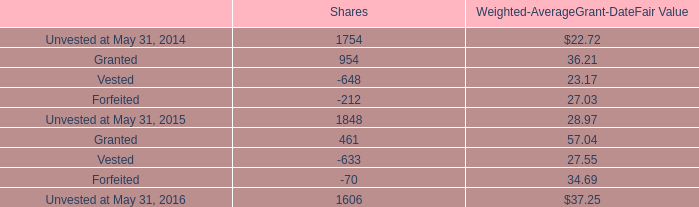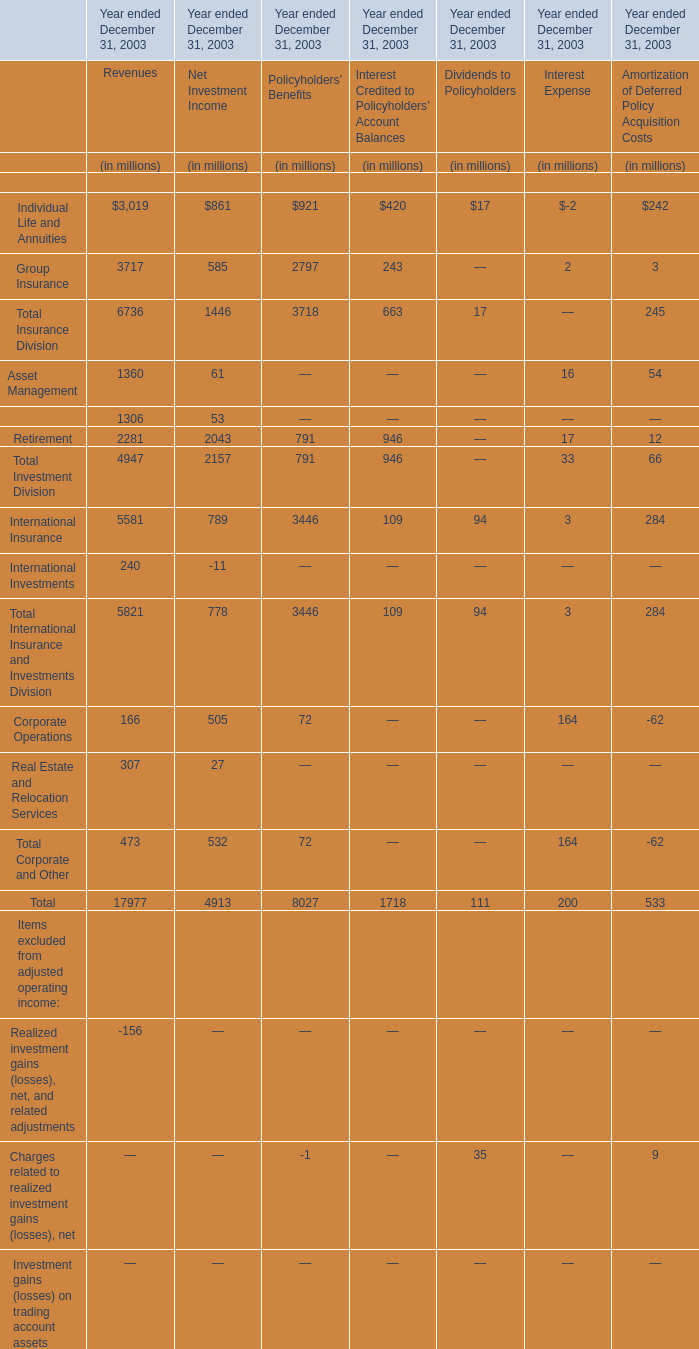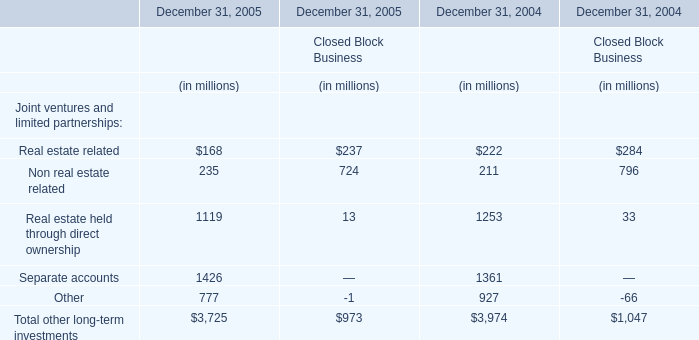In the section with largest amount of Individual Life and Annuities , what's the increasing rate of Total Insurance Division ? 
Computations: ((6736 - 1446) / 6736)
Answer: 0.78533. 